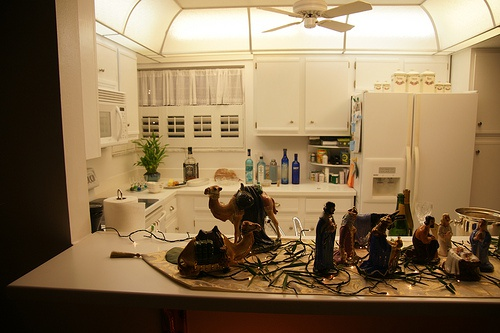Describe the objects in this image and their specific colors. I can see refrigerator in black, tan, and olive tones, people in black, maroon, and tan tones, microwave in black and tan tones, people in black, maroon, and brown tones, and bottle in black, maroon, and tan tones in this image. 